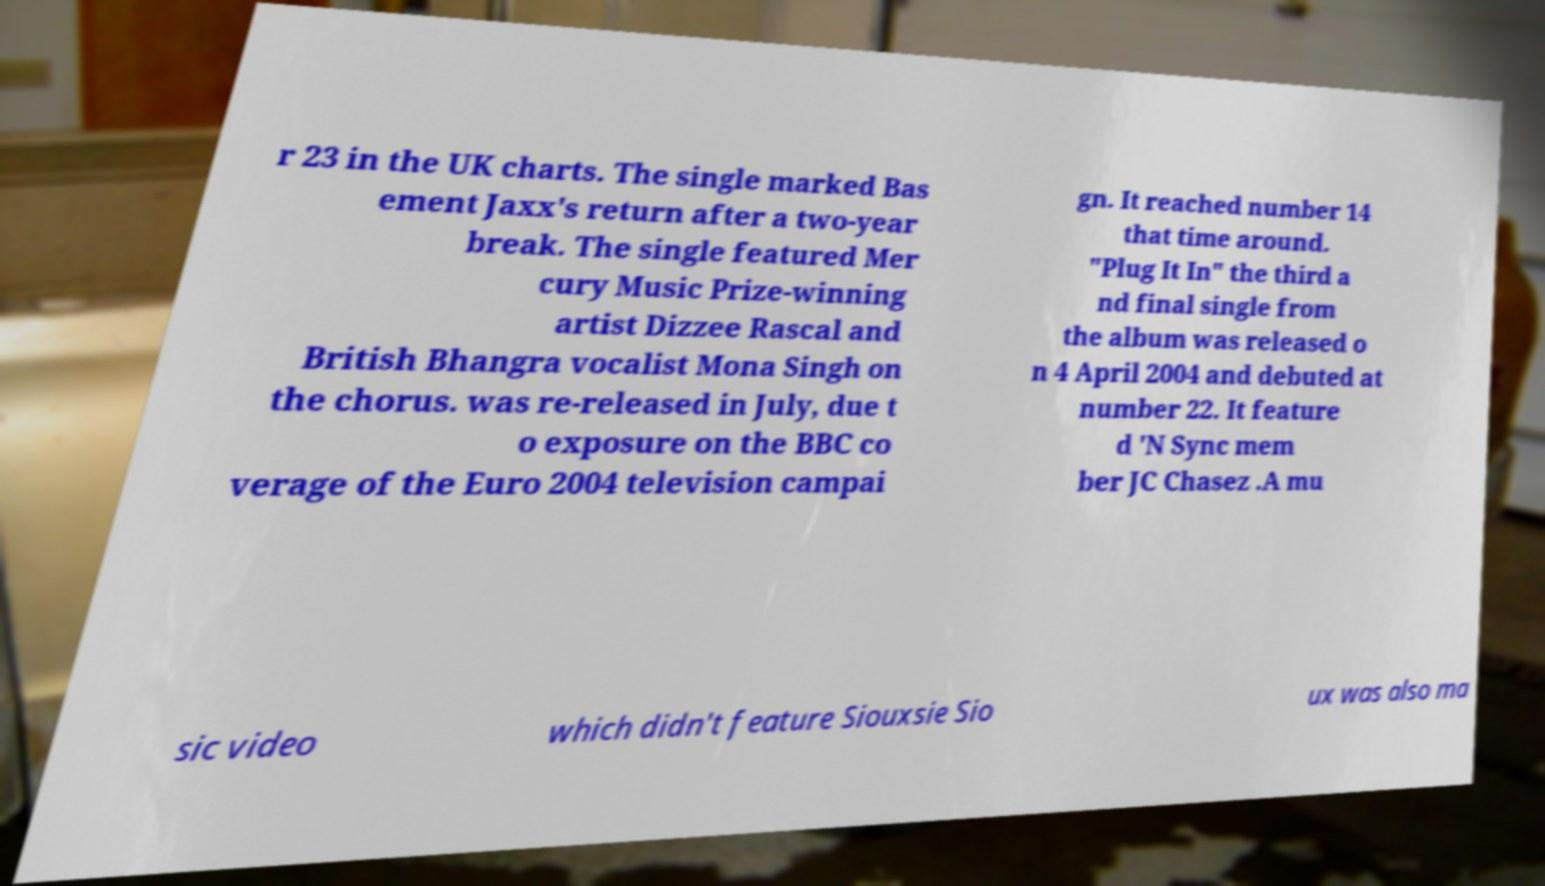I need the written content from this picture converted into text. Can you do that? r 23 in the UK charts. The single marked Bas ement Jaxx's return after a two-year break. The single featured Mer cury Music Prize-winning artist Dizzee Rascal and British Bhangra vocalist Mona Singh on the chorus. was re-released in July, due t o exposure on the BBC co verage of the Euro 2004 television campai gn. It reached number 14 that time around. "Plug It In" the third a nd final single from the album was released o n 4 April 2004 and debuted at number 22. It feature d 'N Sync mem ber JC Chasez .A mu sic video which didn't feature Siouxsie Sio ux was also ma 